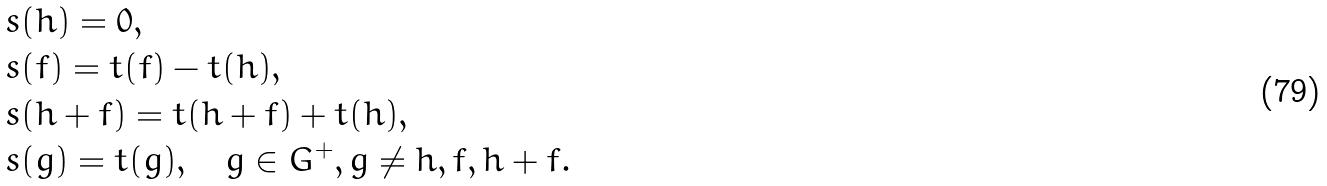Convert formula to latex. <formula><loc_0><loc_0><loc_500><loc_500>& s ( h ) = 0 , \\ & s ( f ) = t ( f ) - t ( h ) , \\ & s ( h + f ) = t ( h + f ) + t ( h ) , \\ & s ( g ) = t ( g ) , \quad g \in G ^ { + } , g \neq h , f , h + f .</formula> 